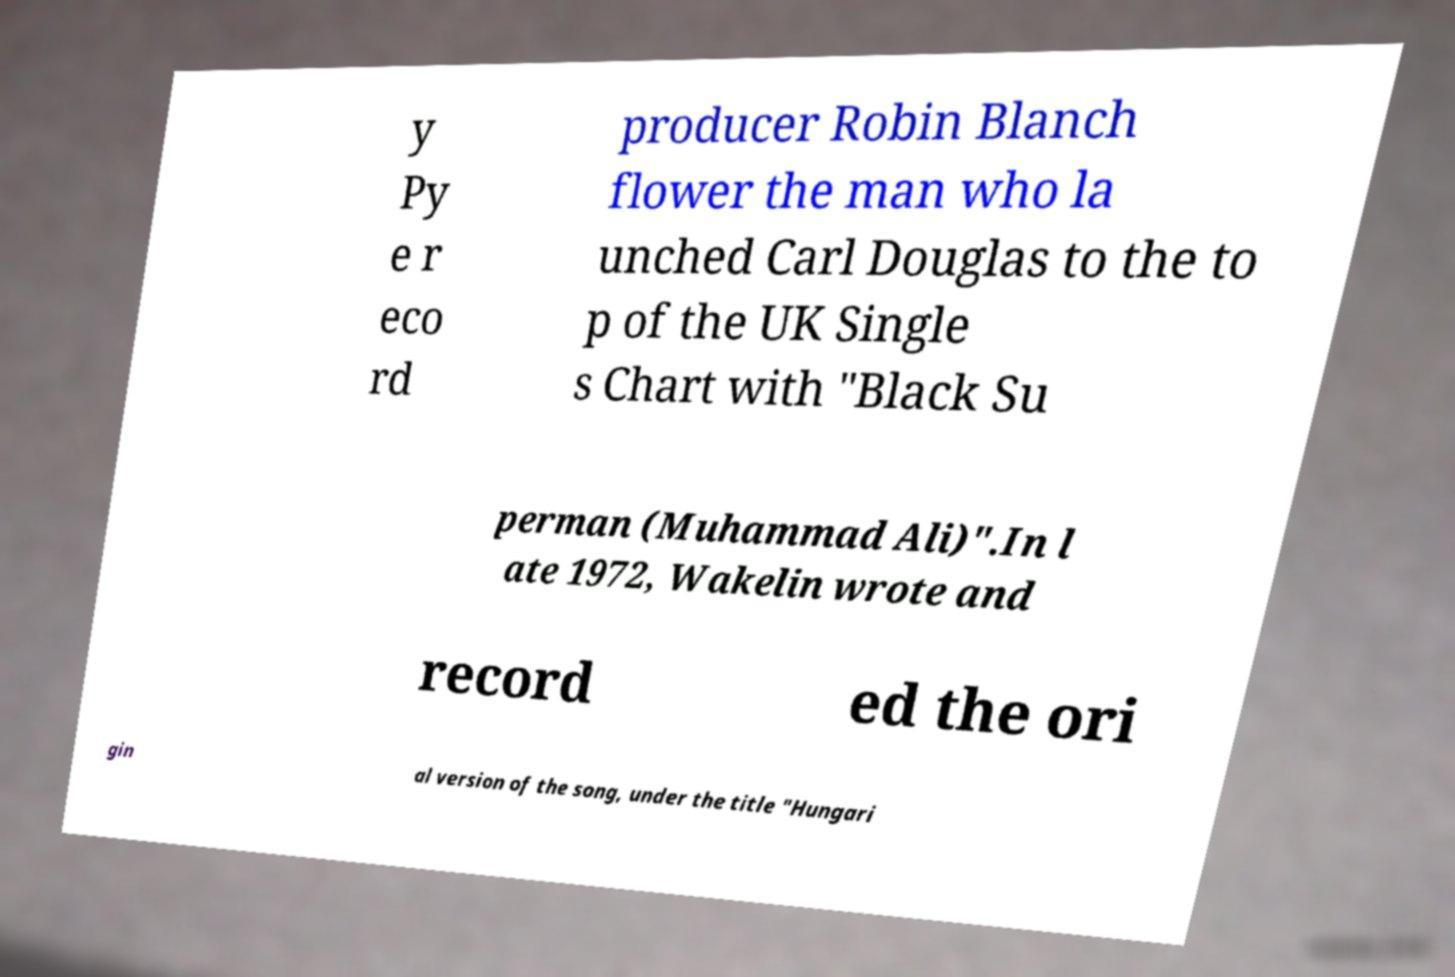I need the written content from this picture converted into text. Can you do that? y Py e r eco rd producer Robin Blanch flower the man who la unched Carl Douglas to the to p of the UK Single s Chart with "Black Su perman (Muhammad Ali)".In l ate 1972, Wakelin wrote and record ed the ori gin al version of the song, under the title "Hungari 